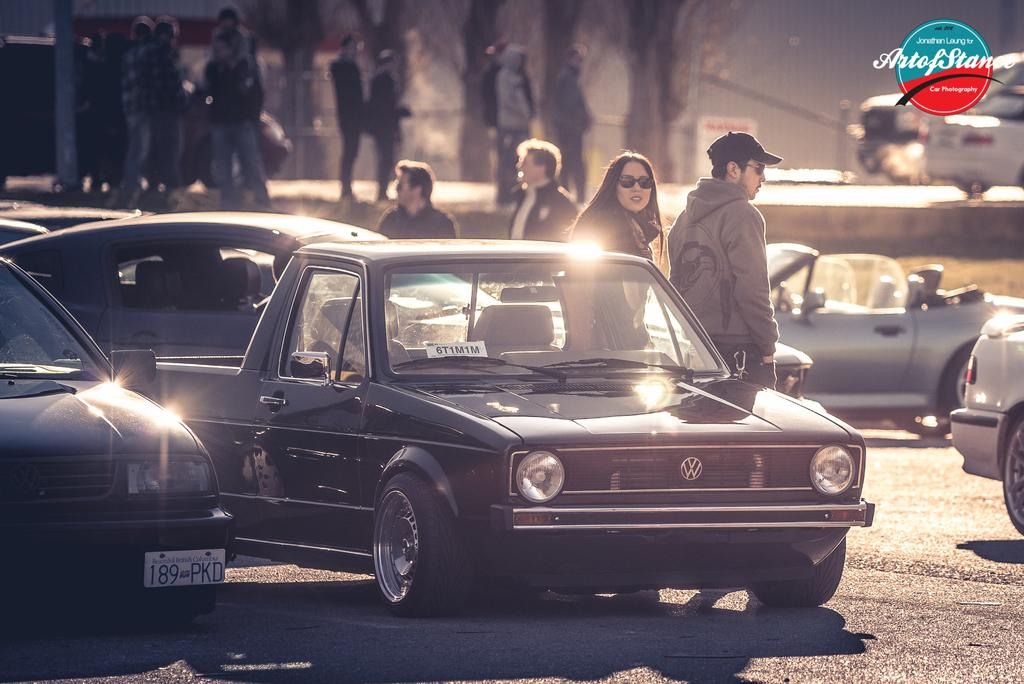What can be seen on the road in the image? There are vehicles on the road in the image. What else is present in the image besides the vehicles? There is a group of people standing in the image. Can you describe any additional features of the image? There is a watermark on the image. What word is being spoken by the dogs in the image? There are no dogs present in the image, so it is not possible to determine what word they might be speaking. 